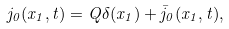<formula> <loc_0><loc_0><loc_500><loc_500>j _ { 0 } ( x _ { 1 } , t ) = Q \delta ( x _ { 1 } ) + \bar { j } _ { 0 } ( x _ { 1 } , t ) ,</formula> 